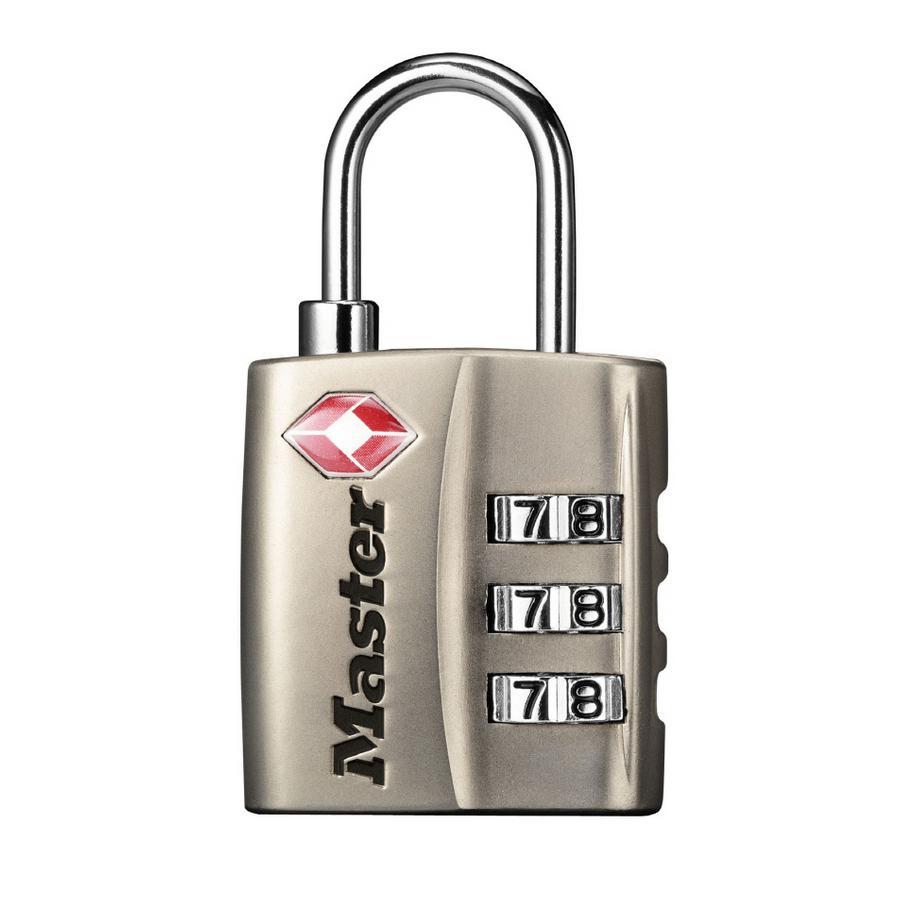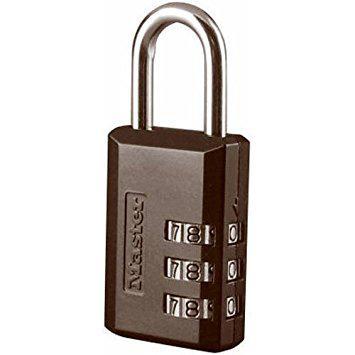The first image is the image on the left, the second image is the image on the right. Analyze the images presented: Is the assertion "Two gold keys sit to the right of a silver padlock with a blue base." valid? Answer yes or no. No. The first image is the image on the left, the second image is the image on the right. For the images displayed, is the sentence "At least one of the padlocks is numbered." factually correct? Answer yes or no. Yes. 